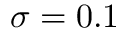<formula> <loc_0><loc_0><loc_500><loc_500>\sigma = 0 . 1</formula> 